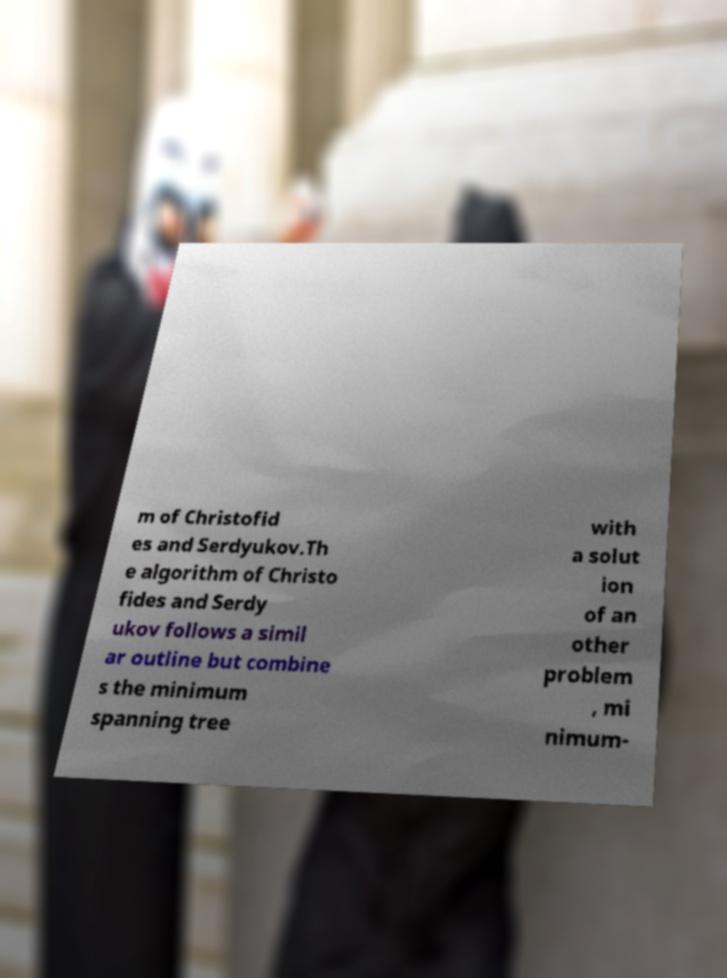Can you read and provide the text displayed in the image?This photo seems to have some interesting text. Can you extract and type it out for me? m of Christofid es and Serdyukov.Th e algorithm of Christo fides and Serdy ukov follows a simil ar outline but combine s the minimum spanning tree with a solut ion of an other problem , mi nimum- 